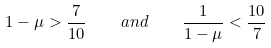Convert formula to latex. <formula><loc_0><loc_0><loc_500><loc_500>1 - \mu > \frac { 7 } { 1 0 } \quad a n d \quad \frac { 1 } { 1 - \mu } < \frac { 1 0 } { 7 }</formula> 